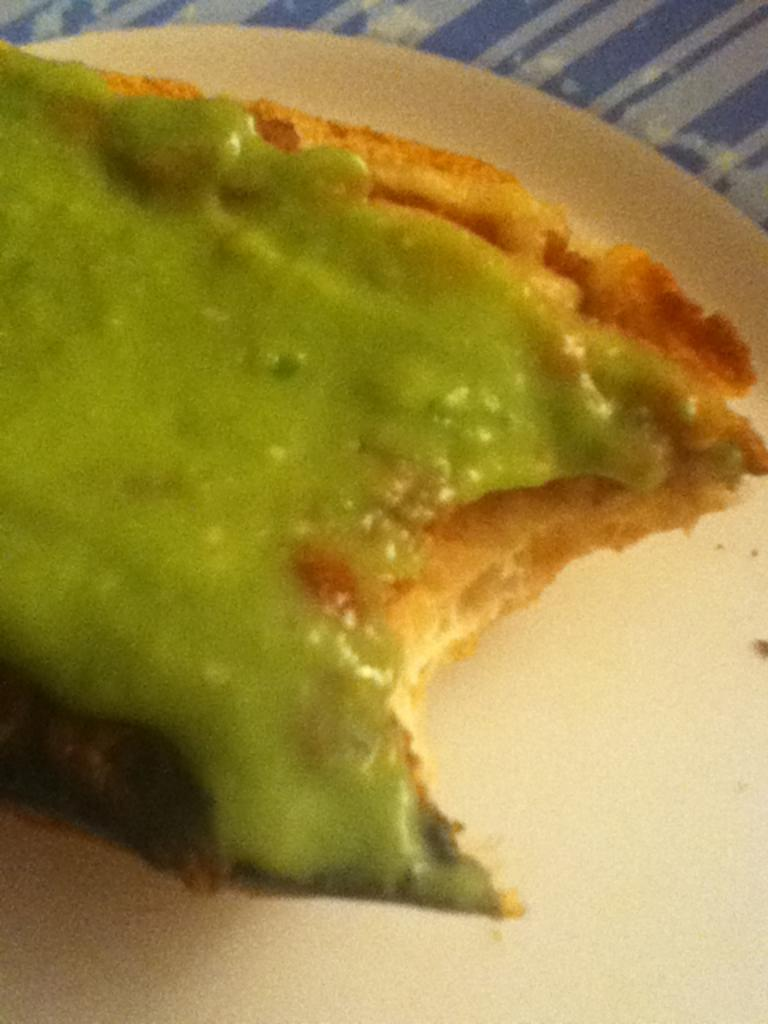What is on the plate that is visible in the image? There is food on a plate in the image. What type of health advice can be found on the plate in the image? There is no health advice present on the plate in the image; it only contains food. 